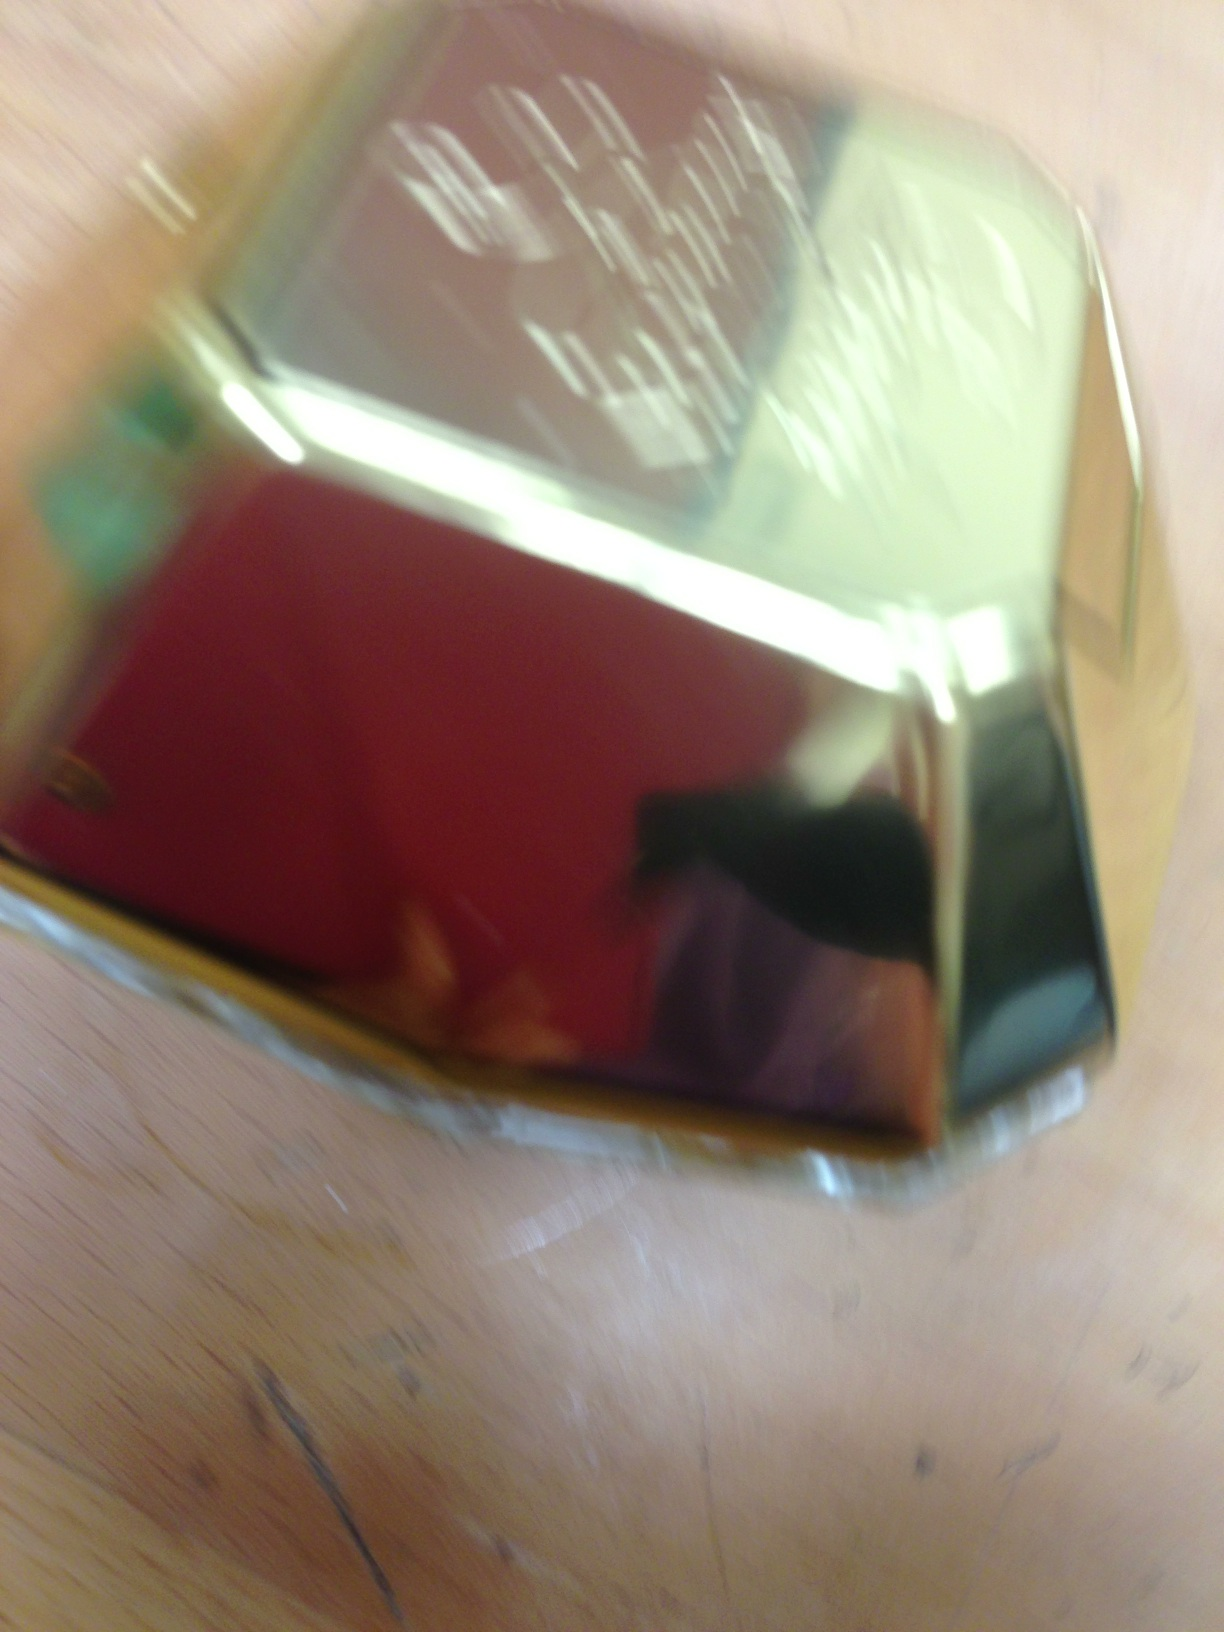You can tell me what kind of perfume is this? The image appears to show a perfume bottle, but it is too blurry to identify specific details such as brand or specific fragrance. 